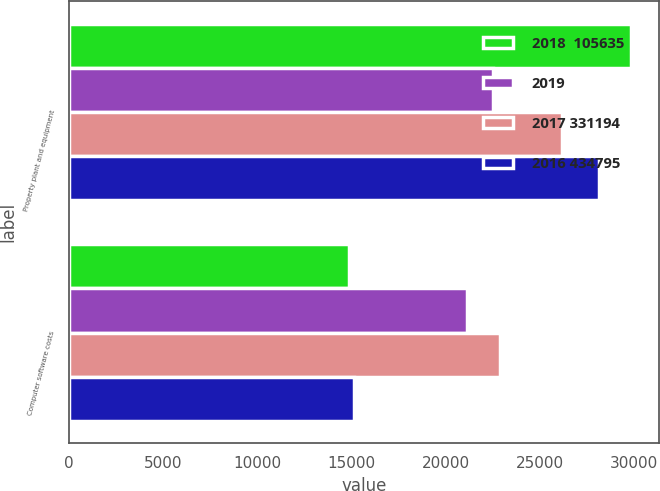Convert chart to OTSL. <chart><loc_0><loc_0><loc_500><loc_500><stacked_bar_chart><ecel><fcel>Property plant and equipment<fcel>Computer software costs<nl><fcel>2018  105635<fcel>29824<fcel>14842<nl><fcel>2019<fcel>22495<fcel>21144<nl><fcel>2017 331194<fcel>26146<fcel>22880<nl><fcel>2016 434795<fcel>28103<fcel>15143<nl></chart> 